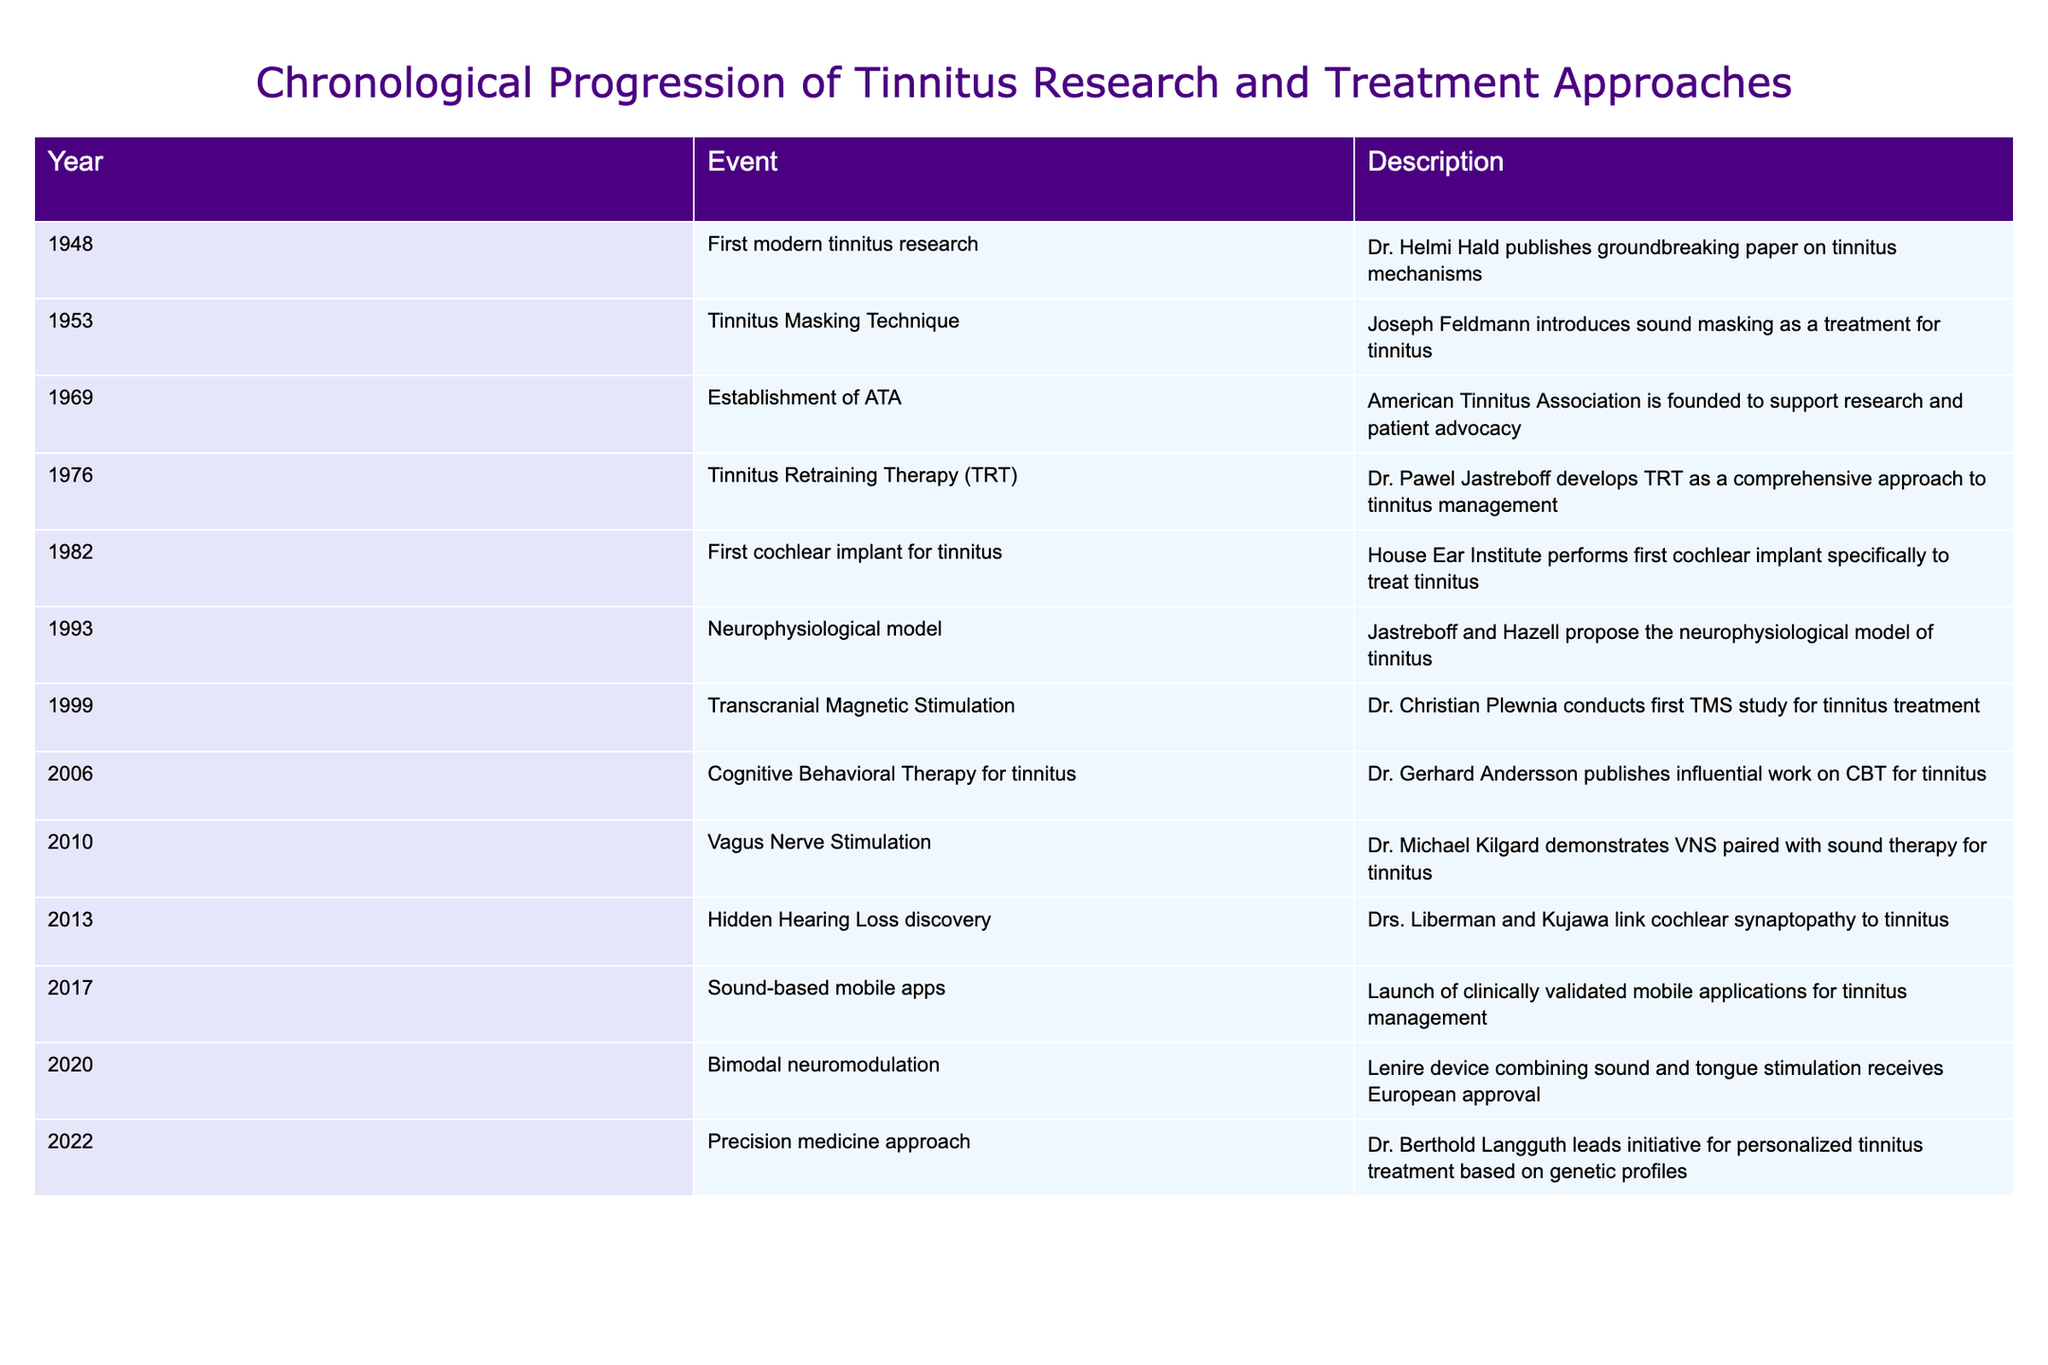What year was the first modern tinnitus research published? The table indicates that the first modern tinnitus research was published in 1948.
Answer: 1948 Who introduced the tinnitus masking technique? From the table, Joseph Feldmann is credited with introducing the tinnitus masking technique in 1953.
Answer: Joseph Feldmann How many years passed between the establishment of the American Tinnitus Association and the development of Tinnitus Retraining Therapy? The American Tinnitus Association was established in 1969, and Tinnitus Retraining Therapy was developed in 1976. The difference is 1976 - 1969 = 7 years.
Answer: 7 years Was Cognitive Behavioral Therapy for tinnitus published before 2010? According to the table, Cognitive Behavioral Therapy for tinnitus was published in 2006, which is before 2010.
Answer: Yes How many significant treatment approaches were developed between 1976 and 2022? The significant treatment approaches developed during this period, listed in the table, are Tinnitus Retraining Therapy (1976), Vagus Nerve Stimulation (2010), and the Precision Medicine approach (2022). This totals to three approaches.
Answer: 3 What was the last event mentioned in the table? The last event in the table is the precision medicine approach led by Dr. Berthold Langguth in 2022.
Answer: Precision medicine approach In which year did the first cochlear implant specifically for tinnitus occur? The table specifies that the first cochlear implant for tinnitus took place in 1982.
Answer: 1982 How many events are listed in the table? By counting the entries in the table, there are 15 distinct events listed regarding the progression of tinnitus research and treatment approaches.
Answer: 15 What is the main theme of the events listed in the table? The main theme is the chronological progression of research and treatment approaches related to tinnitus, highlighting various methods and innovations from 1948 to 2022.
Answer: Tinnitus research and treatment progression 